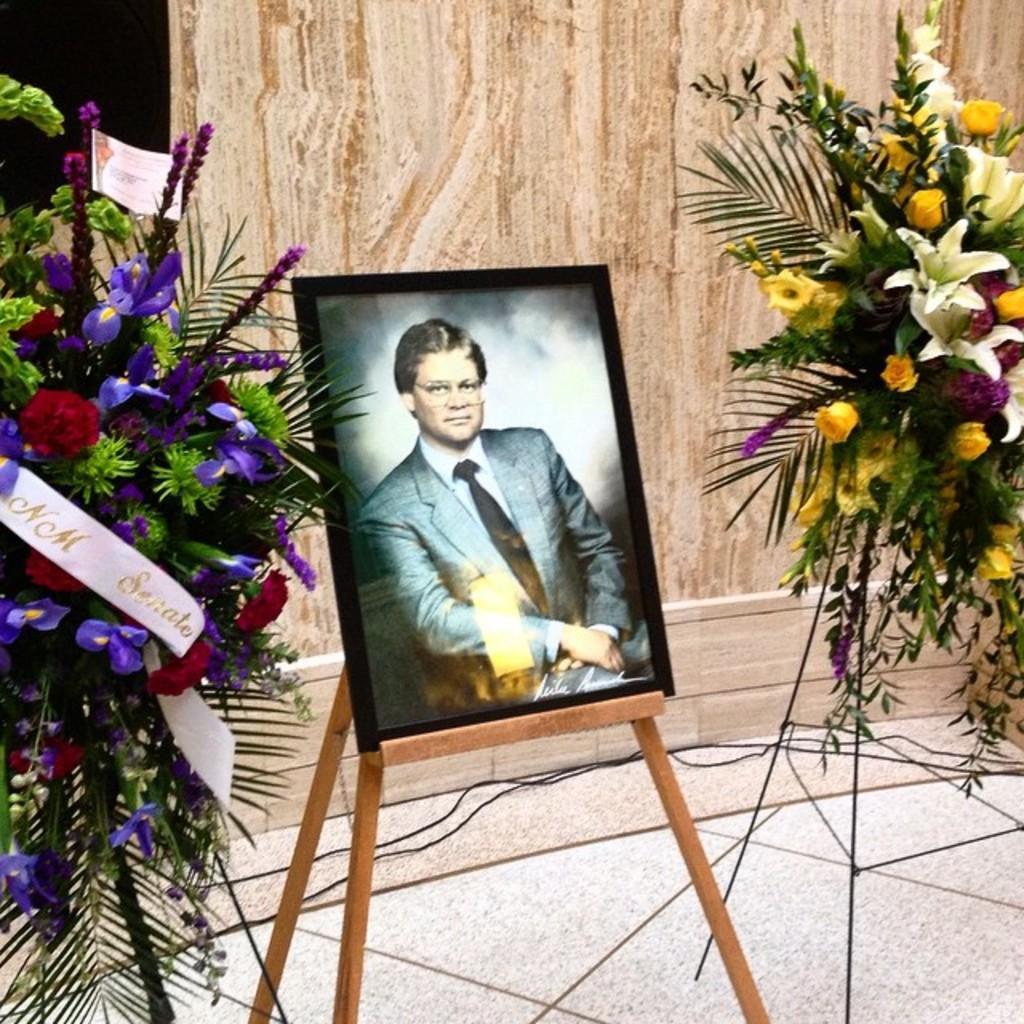Can you describe this image briefly? In this picture we can see a painting of a person and a painting stand in the middle, on the right side and left side there are flower bouquets, in the background there is a wall. 